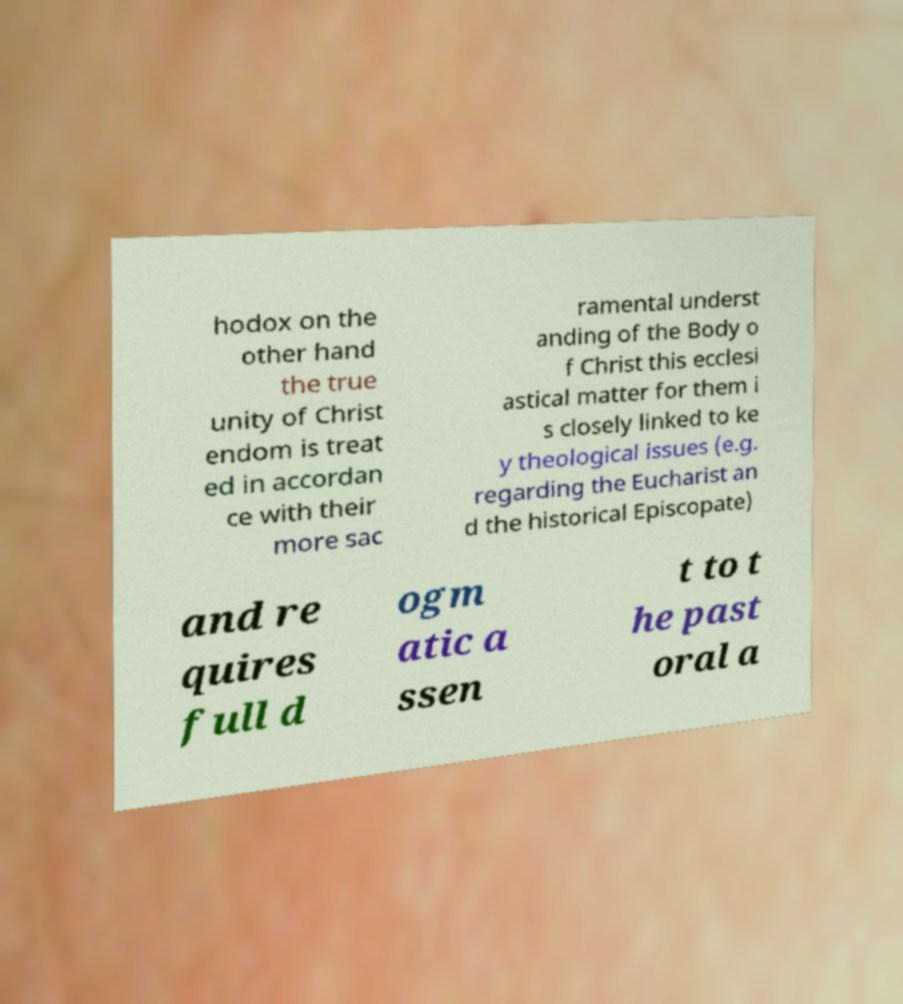Can you accurately transcribe the text from the provided image for me? hodox on the other hand the true unity of Christ endom is treat ed in accordan ce with their more sac ramental underst anding of the Body o f Christ this ecclesi astical matter for them i s closely linked to ke y theological issues (e.g. regarding the Eucharist an d the historical Episcopate) and re quires full d ogm atic a ssen t to t he past oral a 